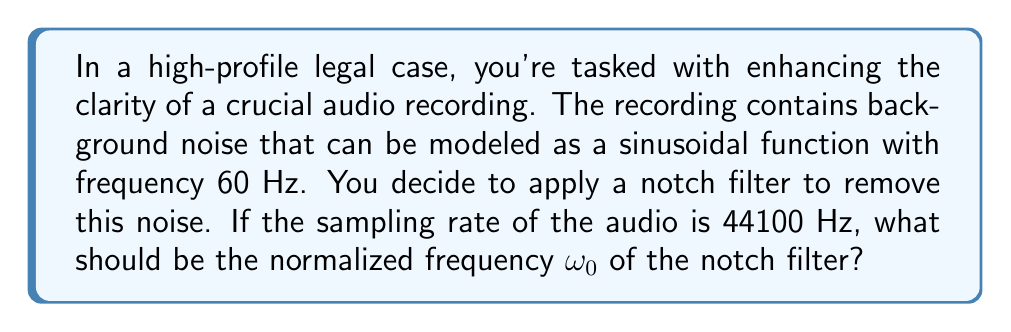Provide a solution to this math problem. To solve this problem, we need to follow these steps:

1) First, recall that the normalized frequency $\omega_0$ is related to the actual frequency $f$ and the sampling rate $f_s$ by the formula:

   $$\omega_0 = \frac{2\pi f}{f_s}$$

2) We are given:
   - The noise frequency $f = 60$ Hz
   - The sampling rate $f_s = 44100$ Hz

3) Let's substitute these values into our formula:

   $$\omega_0 = \frac{2\pi (60)}{44100}$$

4) Simplify:
   
   $$\omega_0 = \frac{120\pi}{44100}$$

5) This can be further simplified to:

   $$\omega_0 = \frac{2\pi}{735}$$

6) If we want to express this as a decimal, we can calculate:

   $$\omega_0 \approx 0.008554$$

The normalized frequency is typically expressed in radians per sample, so we would usually leave the answer in the form $\frac{2\pi}{735}$ or calculate the decimal approximation if requested.
Answer: $\omega_0 = \frac{2\pi}{735}$ radians/sample (or approximately 0.008554 radians/sample) 